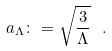Convert formula to latex. <formula><loc_0><loc_0><loc_500><loc_500>a _ { \Lambda } \colon = \sqrt { \frac { 3 } { \Lambda } } \ .</formula> 